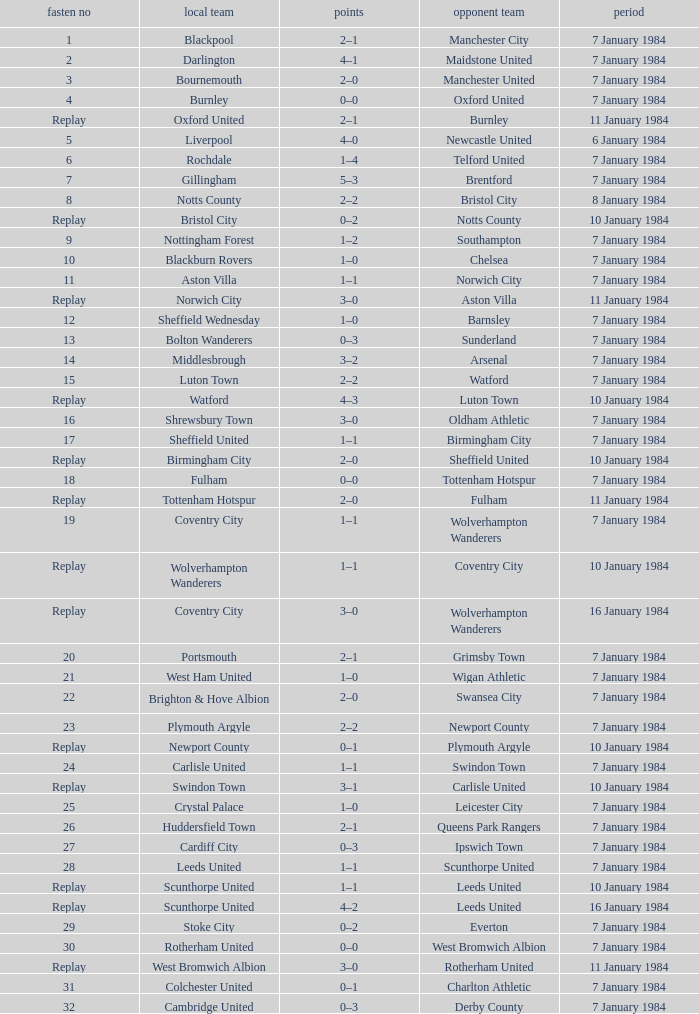Who was the away team against the home team Sheffield United? Birmingham City. 